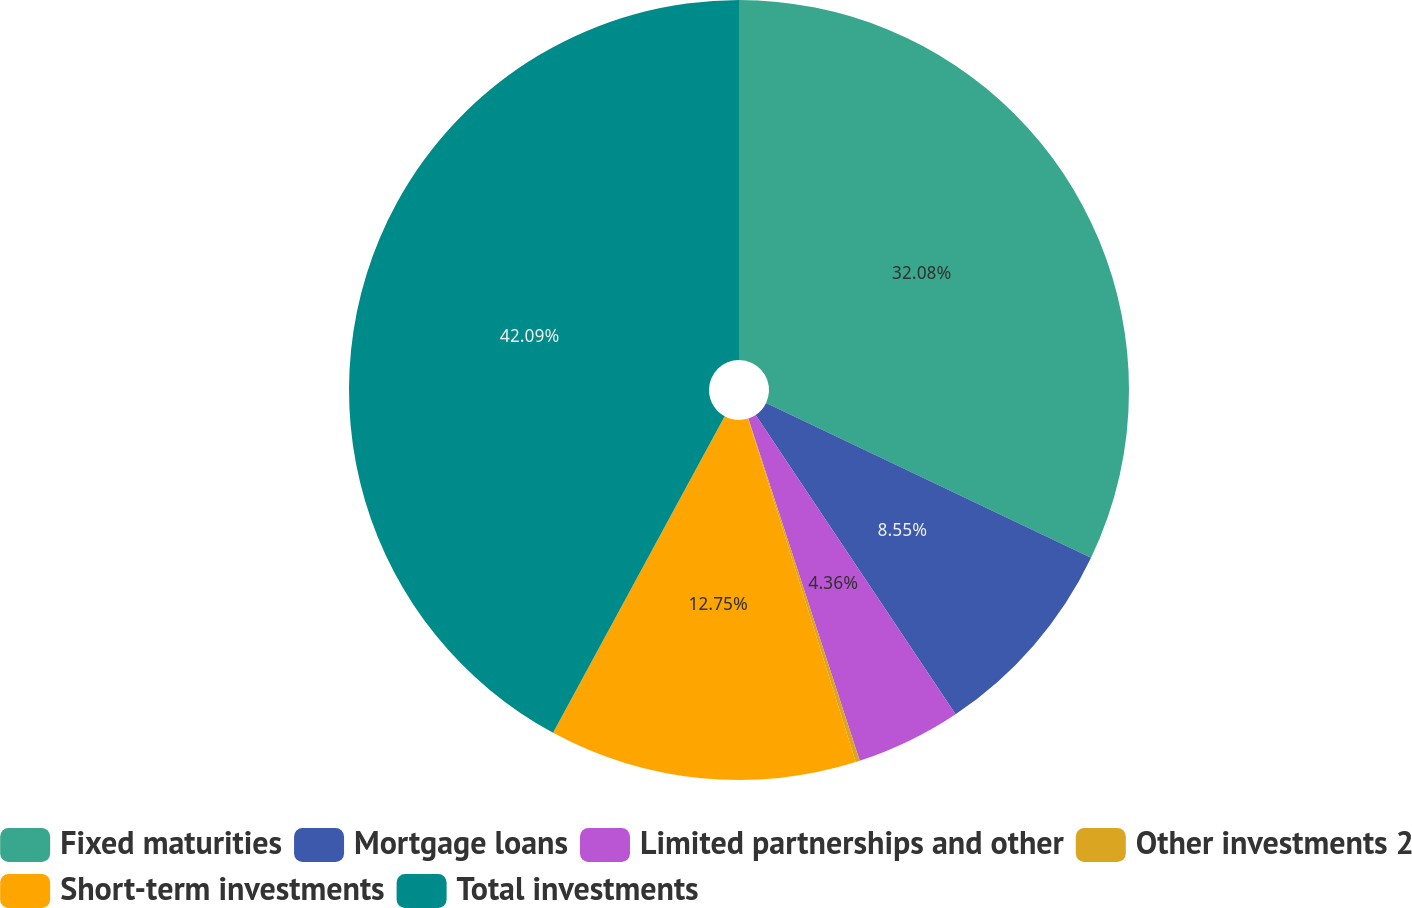<chart> <loc_0><loc_0><loc_500><loc_500><pie_chart><fcel>Fixed maturities<fcel>Mortgage loans<fcel>Limited partnerships and other<fcel>Other investments 2<fcel>Short-term investments<fcel>Total investments<nl><fcel>32.08%<fcel>8.55%<fcel>4.36%<fcel>0.17%<fcel>12.75%<fcel>42.09%<nl></chart> 